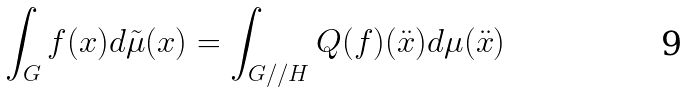<formula> <loc_0><loc_0><loc_500><loc_500>\int _ { G } f ( x ) d \tilde { \mu } ( x ) = \int _ { G / / H } Q ( f ) ( \ddot { x } ) d \mu ( \ddot { x } )</formula> 